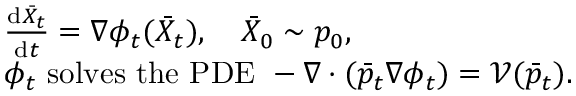<formula> <loc_0><loc_0><loc_500><loc_500>\begin{array} { r l } & { \frac { d \bar { X } _ { t } } { d t } = \nabla \phi _ { t } ( \bar { X } _ { t } ) , \quad \bar { X } _ { 0 } \sim p _ { 0 } , } \\ & { \phi _ { t } s o l v e s t h e P D E - \nabla \cdot ( \bar { p } _ { t } \nabla \phi _ { t } ) = \mathcal { V } ( \bar { p } _ { t } ) . } \end{array}</formula> 